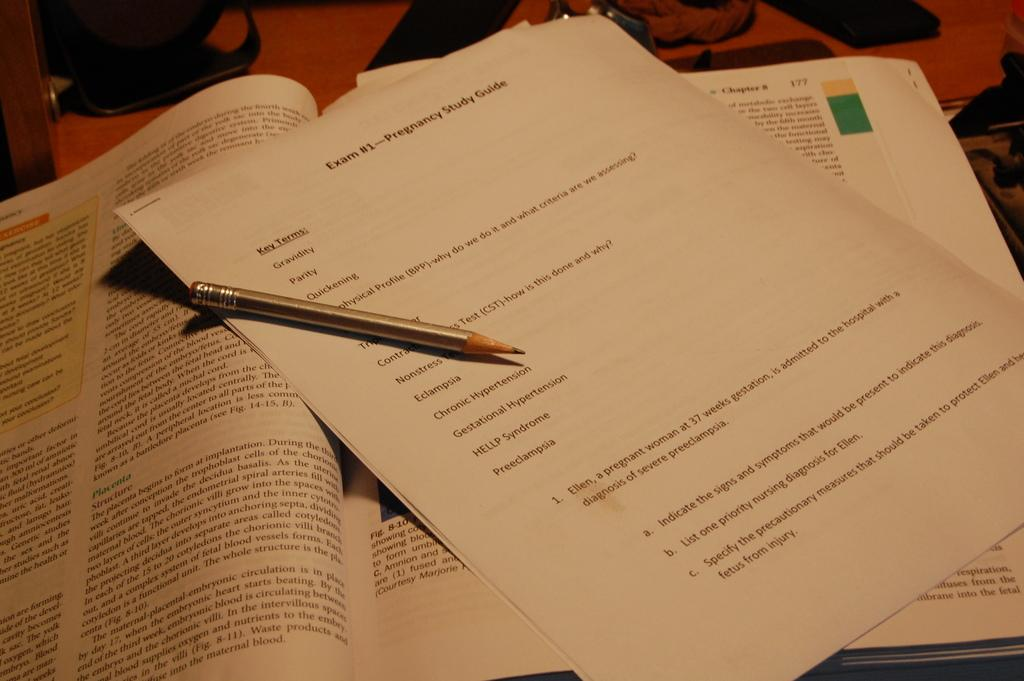What is the main object in the image? There is a book in the image. What other items can be seen in the image? There are papers and a pencil in the image. What might be used for writing or drawing in the image? The pencil in the image can be used for writing or drawing. How many geese are visible in the image? There are no geese are present in the image. What type of monkey can be seen interacting with the book in the image? There is no monkey present in the image; only the book, papers, and pencil are visible. 